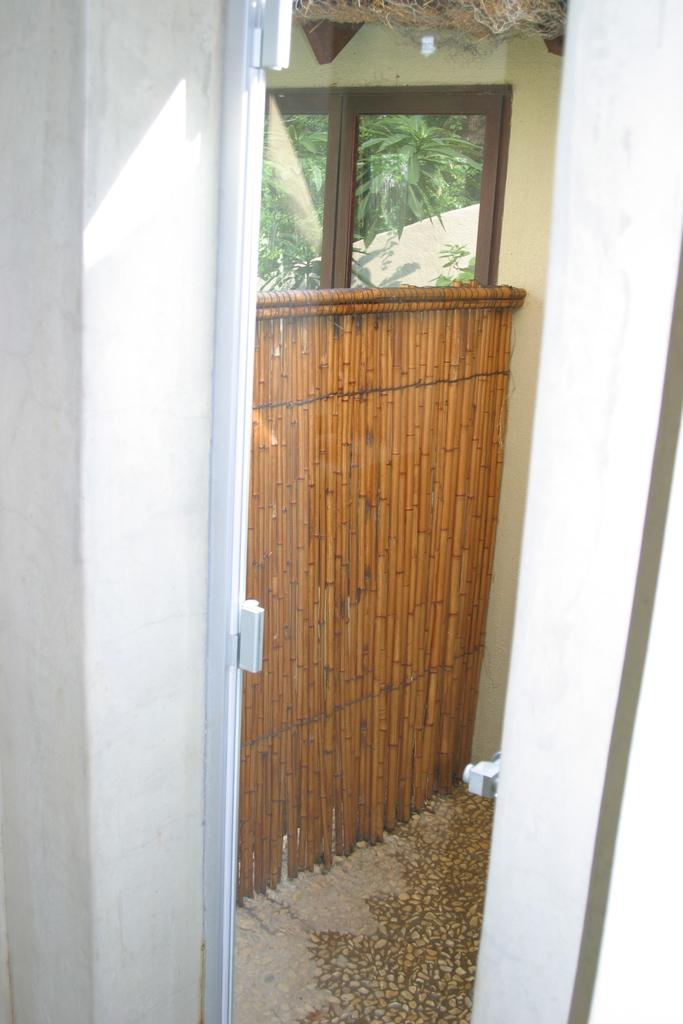What objects are present in the image? There are glasses and a wooden door in the image. What can be seen in the background of the image? Trees are visible in the background of the image. What type of pear is being served at the feast in the image? There is no feast or pear present in the image; it only features glasses, a wooden door, and trees in the background. 